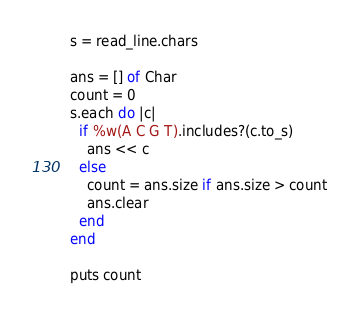<code> <loc_0><loc_0><loc_500><loc_500><_Crystal_>s = read_line.chars

ans = [] of Char
count = 0
s.each do |c|
  if %w(A C G T).includes?(c.to_s)
    ans << c
  else
    count = ans.size if ans.size > count
    ans.clear
  end
end

puts count
</code> 